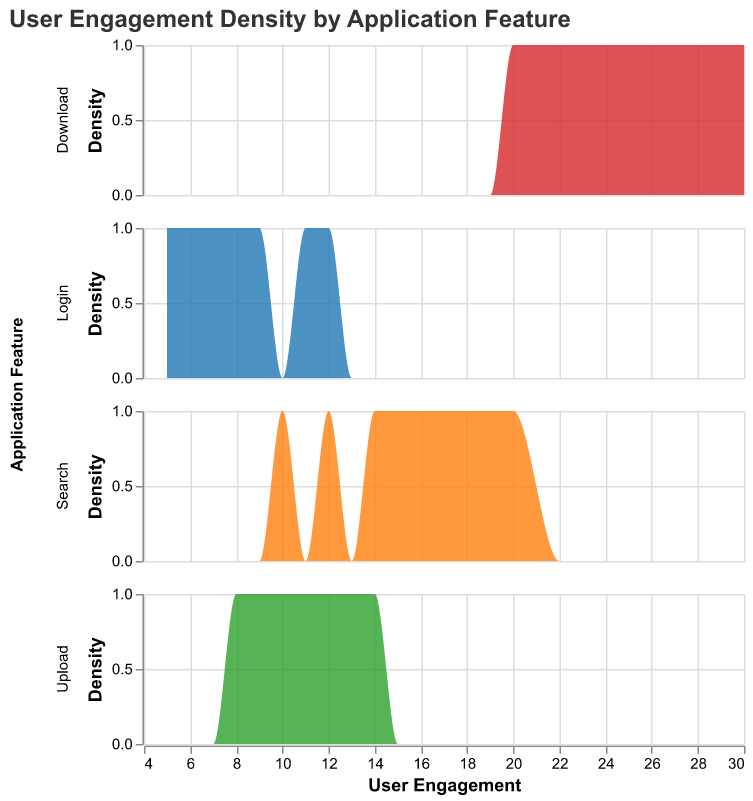What is the title of the plot? The title of the plot is usually placed at the top and is explicitly naming the purpose of the plot.
Answer: User Engagement Density by Application Feature Which feature has the highest user engagement on January 7th? Looking at the plot's color segmentation for the date January 7th, compare the user engagement values of each feature.
Answer: Search What is the density of user engagement for Upload on January 3rd? Find the Upload feature for January 3rd and read the density value from the plot.
Answer: 1 How does user engagement for the Search feature on January 5th compare to January 4th? Look at the user engagement densities for the Search feature on both dates and compare the values directly.
Answer: Higher on January 5th than January 4th What is the average user engagement for the Login feature from January 1st to January 7th? Sum the user engagement values for Login over the given period (5 + 8 + 12 + 6 + 11 + 7 + 9) and divide by the number of days (7).
Answer: (5 + 8 + 12 + 6 + 11 + 7 + 9) / 7 = 8.29 Which feature has the lowest density of user engagement throughout the period? Compare the plots of each feature over the entire period to identify the one with the lowest density overall.
Answer: Upload Between Login and Download, which has a more consistent level of user engagement over time? Examine the density plots for Login and Download, observing the spread and variation in their user engagement values.
Answer: Download What is the peak density value for the Download feature over the time period? Identify the highest point in the density plot line for the Download feature over the entire time period.
Answer: 2 How does the engagement density for Upload on January 2nd compare to that on January 6th? Find and compare the density values for the Upload feature on January 2nd and January 6th from the plot.
Answer: Higher on January 2nd than January 6th Which feature shows the most variability in user engagement? Observe the density plots of all features and determine which one has the widest spread or most fluctuation in density values.
Answer: Search 